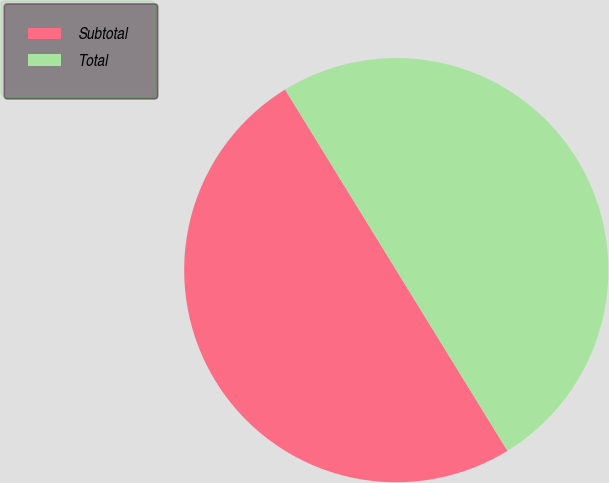Convert chart. <chart><loc_0><loc_0><loc_500><loc_500><pie_chart><fcel>Subtotal<fcel>Total<nl><fcel>50.0%<fcel>50.0%<nl></chart> 